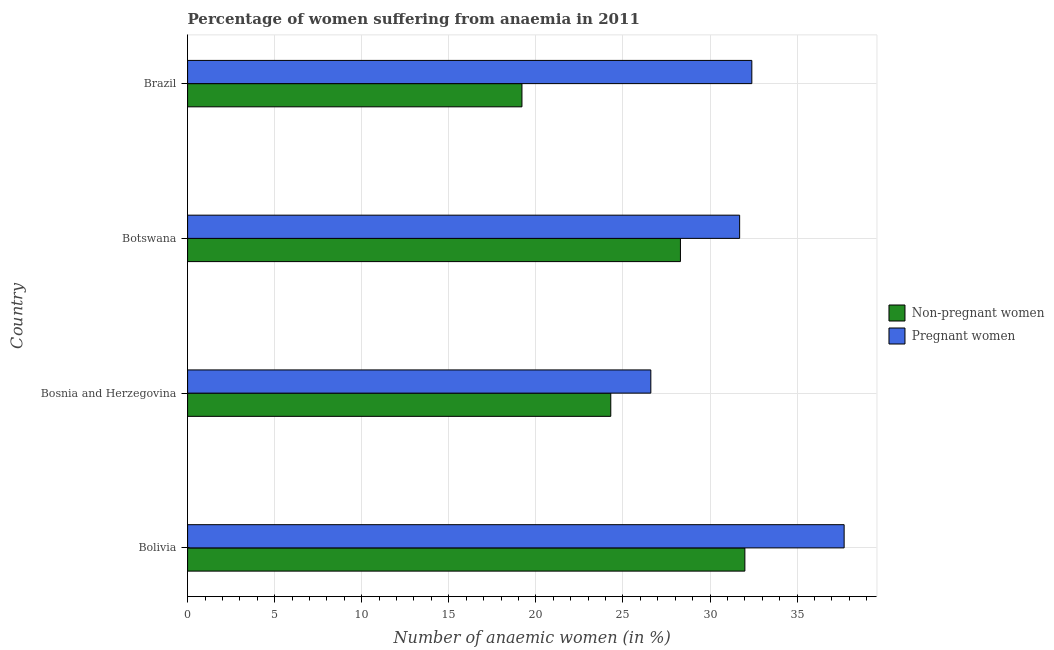How many different coloured bars are there?
Offer a very short reply. 2. Are the number of bars per tick equal to the number of legend labels?
Provide a short and direct response. Yes. Are the number of bars on each tick of the Y-axis equal?
Your answer should be very brief. Yes. How many bars are there on the 3rd tick from the top?
Your answer should be very brief. 2. What is the label of the 2nd group of bars from the top?
Your answer should be compact. Botswana. What is the percentage of pregnant anaemic women in Bosnia and Herzegovina?
Your answer should be very brief. 26.6. Across all countries, what is the maximum percentage of non-pregnant anaemic women?
Your response must be concise. 32. Across all countries, what is the minimum percentage of pregnant anaemic women?
Give a very brief answer. 26.6. In which country was the percentage of pregnant anaemic women minimum?
Offer a very short reply. Bosnia and Herzegovina. What is the total percentage of pregnant anaemic women in the graph?
Your answer should be very brief. 128.4. What is the difference between the percentage of non-pregnant anaemic women in Brazil and the percentage of pregnant anaemic women in Bolivia?
Ensure brevity in your answer.  -18.5. What is the average percentage of pregnant anaemic women per country?
Ensure brevity in your answer.  32.1. In how many countries, is the percentage of pregnant anaemic women greater than 7 %?
Offer a very short reply. 4. In how many countries, is the percentage of pregnant anaemic women greater than the average percentage of pregnant anaemic women taken over all countries?
Provide a succinct answer. 2. Is the sum of the percentage of pregnant anaemic women in Botswana and Brazil greater than the maximum percentage of non-pregnant anaemic women across all countries?
Your answer should be compact. Yes. What does the 1st bar from the top in Brazil represents?
Make the answer very short. Pregnant women. What does the 1st bar from the bottom in Botswana represents?
Offer a very short reply. Non-pregnant women. How many bars are there?
Keep it short and to the point. 8. What is the difference between two consecutive major ticks on the X-axis?
Provide a short and direct response. 5. Does the graph contain any zero values?
Your response must be concise. No. Where does the legend appear in the graph?
Provide a succinct answer. Center right. What is the title of the graph?
Provide a short and direct response. Percentage of women suffering from anaemia in 2011. Does "Nitrous oxide emissions" appear as one of the legend labels in the graph?
Keep it short and to the point. No. What is the label or title of the X-axis?
Provide a short and direct response. Number of anaemic women (in %). What is the label or title of the Y-axis?
Provide a short and direct response. Country. What is the Number of anaemic women (in %) of Non-pregnant women in Bolivia?
Provide a short and direct response. 32. What is the Number of anaemic women (in %) of Pregnant women in Bolivia?
Your answer should be very brief. 37.7. What is the Number of anaemic women (in %) in Non-pregnant women in Bosnia and Herzegovina?
Keep it short and to the point. 24.3. What is the Number of anaemic women (in %) in Pregnant women in Bosnia and Herzegovina?
Your answer should be compact. 26.6. What is the Number of anaemic women (in %) of Non-pregnant women in Botswana?
Offer a terse response. 28.3. What is the Number of anaemic women (in %) in Pregnant women in Botswana?
Your answer should be very brief. 31.7. What is the Number of anaemic women (in %) of Pregnant women in Brazil?
Your answer should be compact. 32.4. Across all countries, what is the maximum Number of anaemic women (in %) of Non-pregnant women?
Provide a short and direct response. 32. Across all countries, what is the maximum Number of anaemic women (in %) of Pregnant women?
Ensure brevity in your answer.  37.7. Across all countries, what is the minimum Number of anaemic women (in %) of Pregnant women?
Provide a succinct answer. 26.6. What is the total Number of anaemic women (in %) of Non-pregnant women in the graph?
Your answer should be very brief. 103.8. What is the total Number of anaemic women (in %) of Pregnant women in the graph?
Your answer should be very brief. 128.4. What is the difference between the Number of anaemic women (in %) in Pregnant women in Bolivia and that in Bosnia and Herzegovina?
Provide a succinct answer. 11.1. What is the difference between the Number of anaemic women (in %) of Pregnant women in Bosnia and Herzegovina and that in Botswana?
Make the answer very short. -5.1. What is the difference between the Number of anaemic women (in %) in Non-pregnant women in Botswana and that in Brazil?
Give a very brief answer. 9.1. What is the difference between the Number of anaemic women (in %) of Pregnant women in Botswana and that in Brazil?
Make the answer very short. -0.7. What is the difference between the Number of anaemic women (in %) of Non-pregnant women in Bosnia and Herzegovina and the Number of anaemic women (in %) of Pregnant women in Brazil?
Your response must be concise. -8.1. What is the difference between the Number of anaemic women (in %) of Non-pregnant women in Botswana and the Number of anaemic women (in %) of Pregnant women in Brazil?
Make the answer very short. -4.1. What is the average Number of anaemic women (in %) in Non-pregnant women per country?
Provide a short and direct response. 25.95. What is the average Number of anaemic women (in %) in Pregnant women per country?
Your response must be concise. 32.1. What is the difference between the Number of anaemic women (in %) in Non-pregnant women and Number of anaemic women (in %) in Pregnant women in Botswana?
Ensure brevity in your answer.  -3.4. What is the ratio of the Number of anaemic women (in %) in Non-pregnant women in Bolivia to that in Bosnia and Herzegovina?
Offer a very short reply. 1.32. What is the ratio of the Number of anaemic women (in %) of Pregnant women in Bolivia to that in Bosnia and Herzegovina?
Your answer should be compact. 1.42. What is the ratio of the Number of anaemic women (in %) of Non-pregnant women in Bolivia to that in Botswana?
Your answer should be very brief. 1.13. What is the ratio of the Number of anaemic women (in %) in Pregnant women in Bolivia to that in Botswana?
Ensure brevity in your answer.  1.19. What is the ratio of the Number of anaemic women (in %) of Pregnant women in Bolivia to that in Brazil?
Your answer should be very brief. 1.16. What is the ratio of the Number of anaemic women (in %) of Non-pregnant women in Bosnia and Herzegovina to that in Botswana?
Offer a terse response. 0.86. What is the ratio of the Number of anaemic women (in %) in Pregnant women in Bosnia and Herzegovina to that in Botswana?
Provide a short and direct response. 0.84. What is the ratio of the Number of anaemic women (in %) in Non-pregnant women in Bosnia and Herzegovina to that in Brazil?
Give a very brief answer. 1.27. What is the ratio of the Number of anaemic women (in %) in Pregnant women in Bosnia and Herzegovina to that in Brazil?
Ensure brevity in your answer.  0.82. What is the ratio of the Number of anaemic women (in %) in Non-pregnant women in Botswana to that in Brazil?
Provide a short and direct response. 1.47. What is the ratio of the Number of anaemic women (in %) in Pregnant women in Botswana to that in Brazil?
Give a very brief answer. 0.98. What is the difference between the highest and the lowest Number of anaemic women (in %) of Pregnant women?
Your answer should be compact. 11.1. 